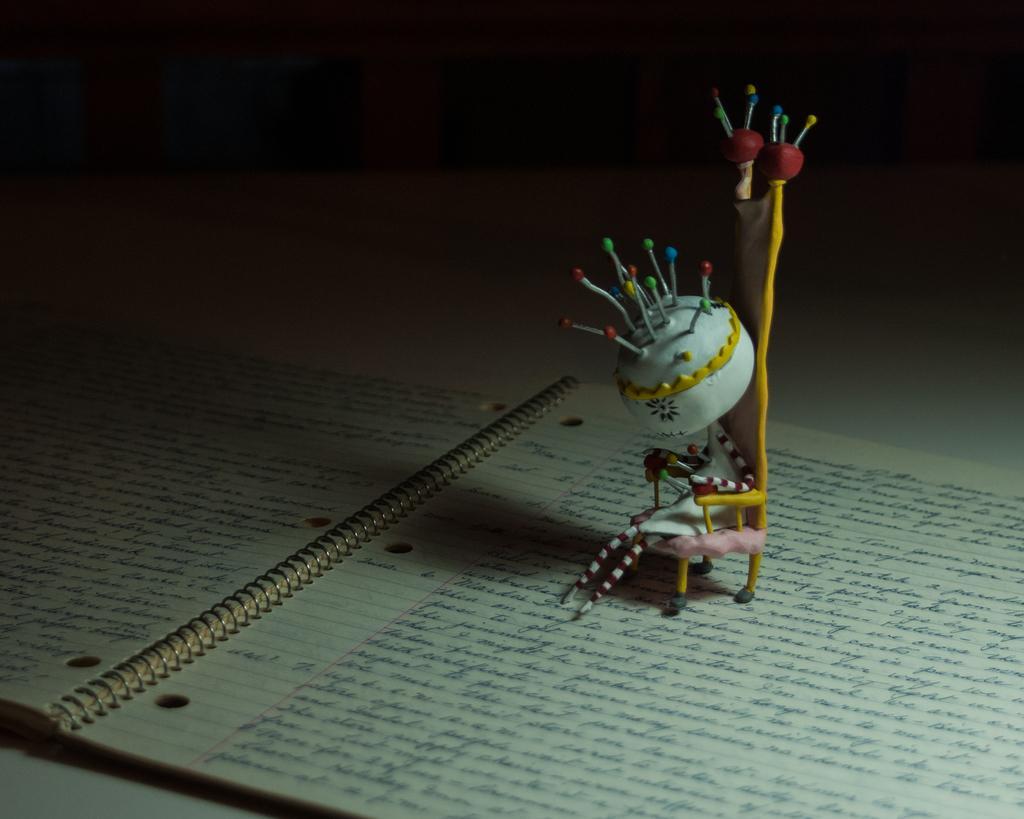Could you give a brief overview of what you see in this image? In this picture we can see there are toys on the book. On the papers, it is written something. Behind the toys there is the dark background. 